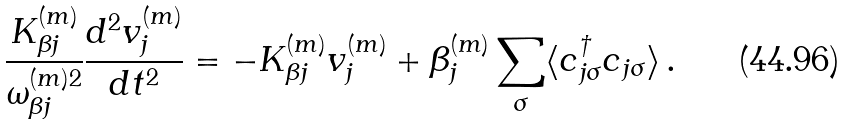Convert formula to latex. <formula><loc_0><loc_0><loc_500><loc_500>\frac { K _ { \beta j } ^ { ( m ) } } { \omega _ { \beta j } ^ { ( m ) 2 } } \frac { d ^ { 2 } v _ { j } ^ { ( m ) } } { d t ^ { 2 } } = - K _ { \beta j } ^ { ( m ) } v _ { j } ^ { ( m ) } + \beta _ { j } ^ { ( m ) } \sum _ { \sigma } \langle c _ { j \sigma } ^ { \dagger } c _ { j \sigma } \rangle \, .</formula> 